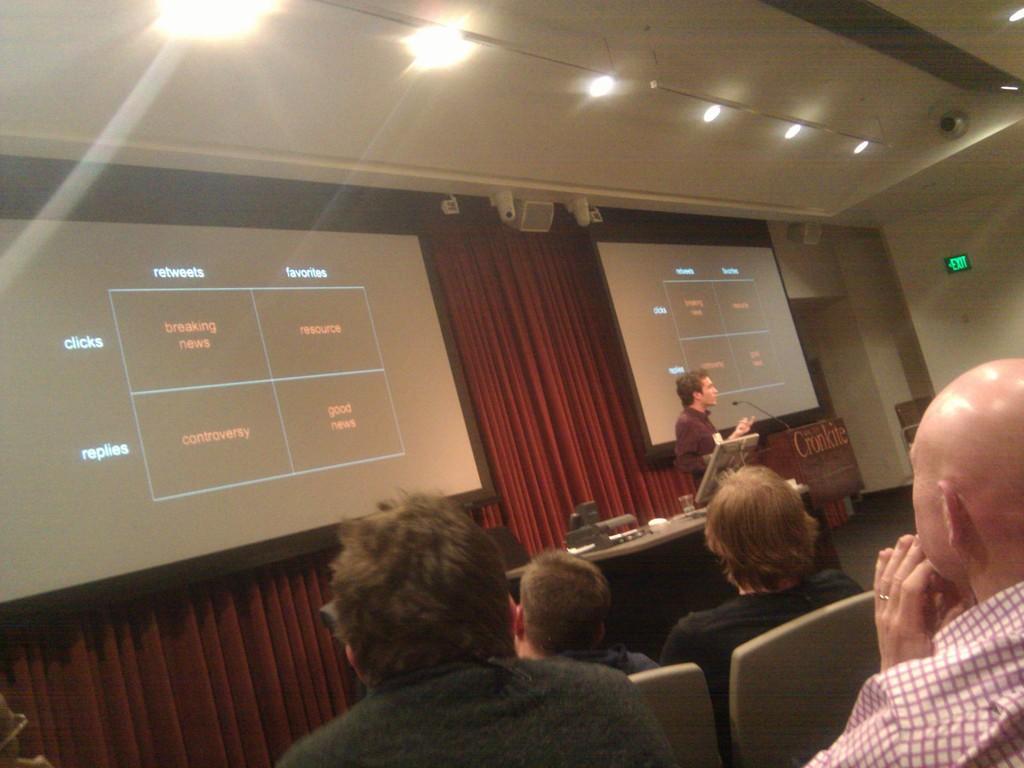In one or two sentences, can you explain what this image depicts? This is an inside view. At the bottom there are few people sitting on the chairs facing towards the back side. In the background there is a person standing in front of the podium and speaking on the mike. Beside this person there is a table on which few objects are placed. On the left side there are two screens on which I can see the text. Behind there is a curtain. At the top of the image there are few lights to the roof. 